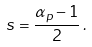Convert formula to latex. <formula><loc_0><loc_0><loc_500><loc_500>s = \frac { \alpha _ { p } - 1 } { 2 } \, .</formula> 